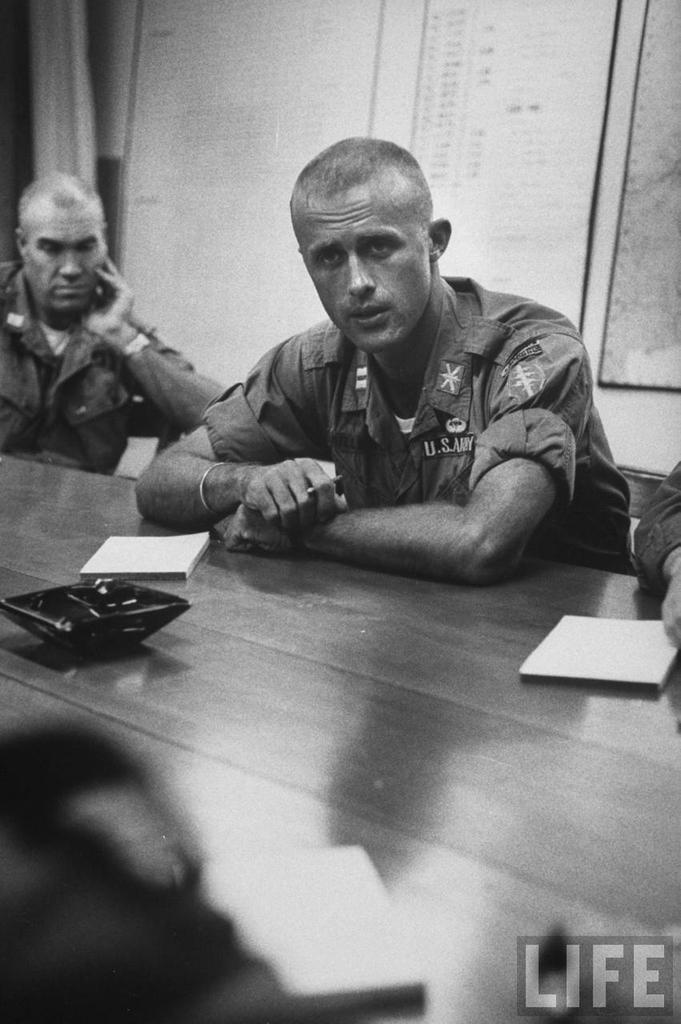In one or two sentences, can you explain what this image depicts? in this image some people is sitting on the chair in front of the table and table has some books and something is there on the table and the background is dark. 